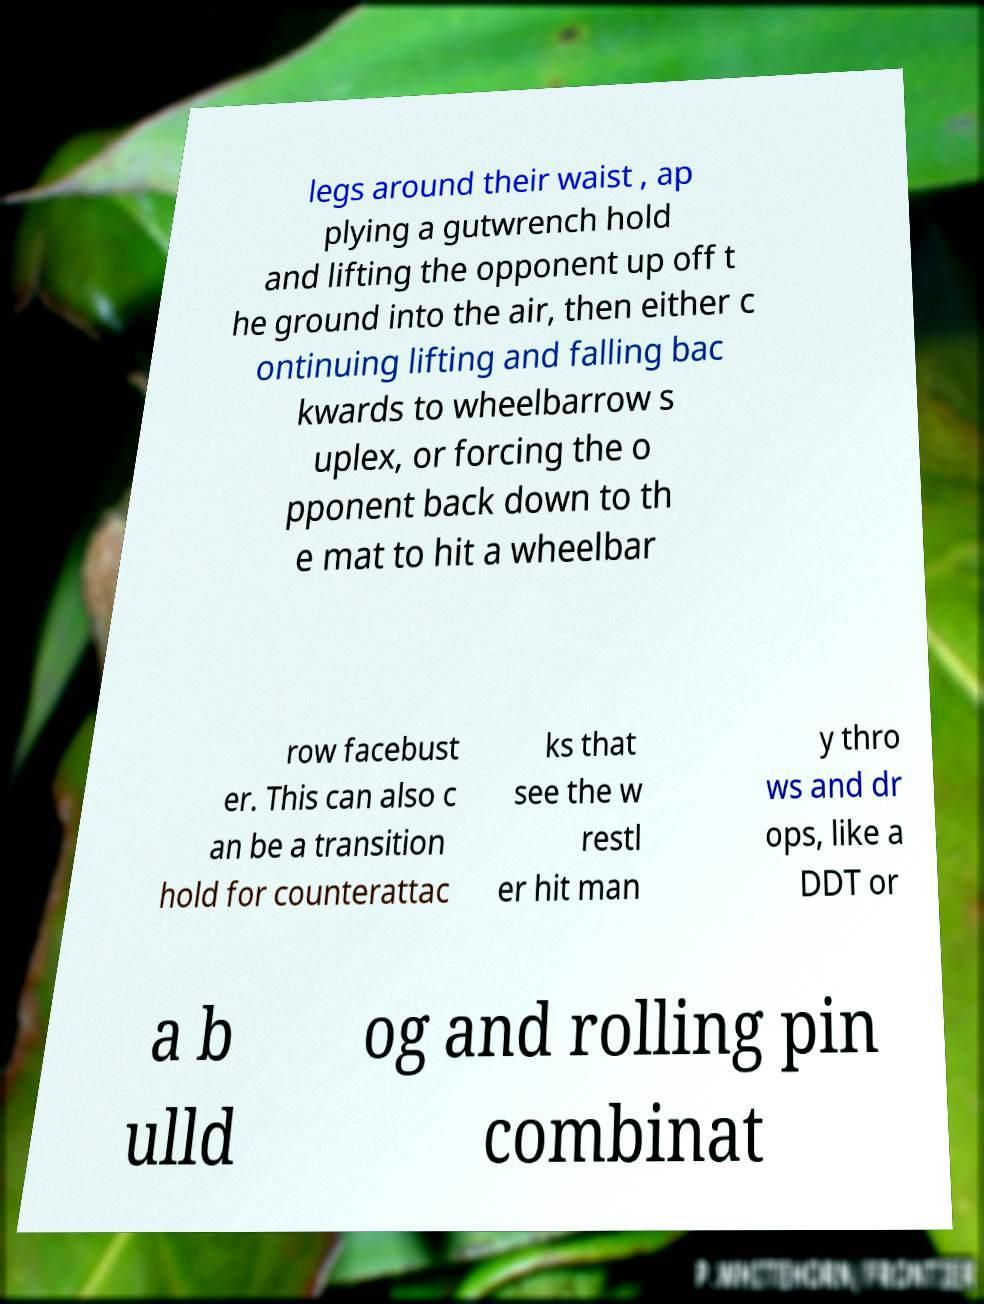Could you assist in decoding the text presented in this image and type it out clearly? legs around their waist , ap plying a gutwrench hold and lifting the opponent up off t he ground into the air, then either c ontinuing lifting and falling bac kwards to wheelbarrow s uplex, or forcing the o pponent back down to th e mat to hit a wheelbar row facebust er. This can also c an be a transition hold for counterattac ks that see the w restl er hit man y thro ws and dr ops, like a DDT or a b ulld og and rolling pin combinat 